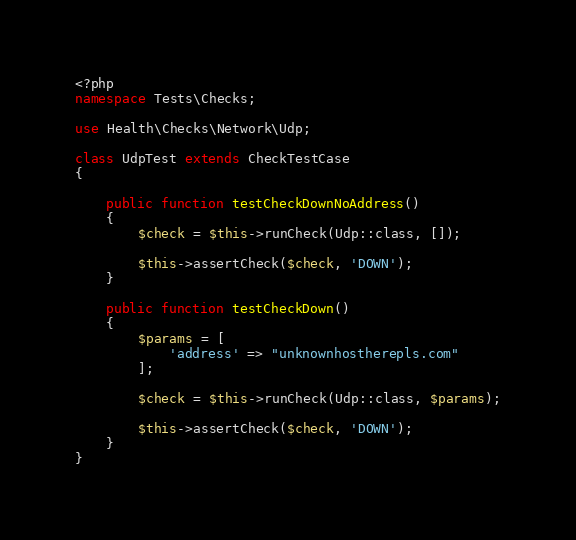Convert code to text. <code><loc_0><loc_0><loc_500><loc_500><_PHP_><?php
namespace Tests\Checks;

use Health\Checks\Network\Udp;

class UdpTest extends CheckTestCase
{

    public function testCheckDownNoAddress()
    {
        $check = $this->runCheck(Udp::class, []);

        $this->assertCheck($check, 'DOWN');
    }

    public function testCheckDown()
    {
        $params = [
            'address' => "unknownhostherepls.com"
        ];

        $check = $this->runCheck(Udp::class, $params);

        $this->assertCheck($check, 'DOWN');
    }
}</code> 